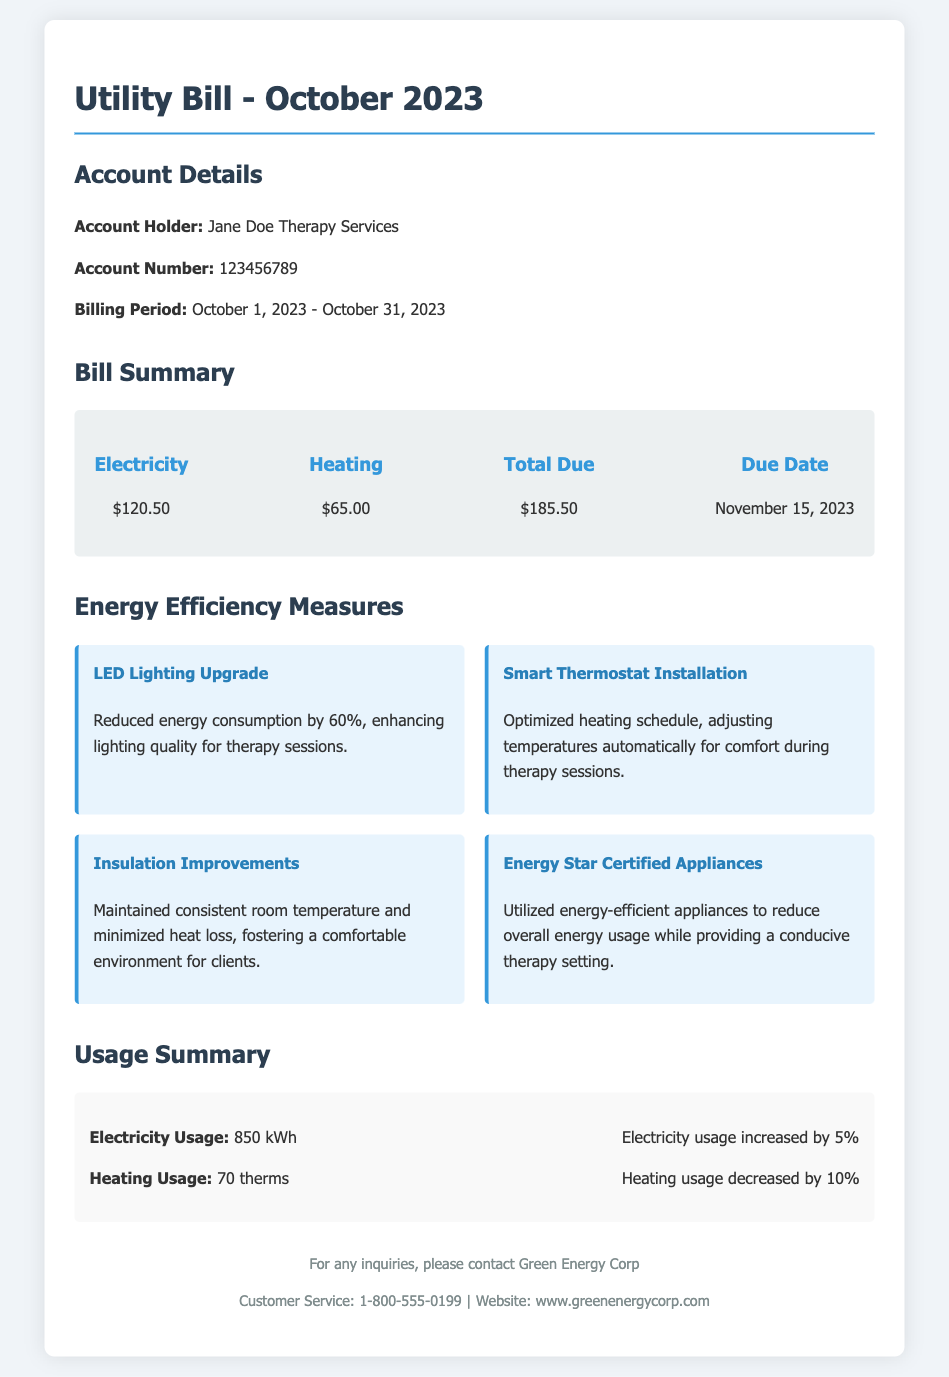what is the electricity cost? The electricity cost listed in the bill summary is clearly stated as $120.50.
Answer: $120.50 what is the heating cost? The heating cost for the billing period is provided in the bill summary, which is $65.00.
Answer: $65.00 what is the total amount due? The total amount due is the sum of electricity and heating costs, found in the bill summary as $185.50.
Answer: $185.50 when is the due date? The due date for payment of the bill is specified as November 15, 2023.
Answer: November 15, 2023 how much did electricity usage increase? The document states that electricity usage increased by 5% compared to the previous period.
Answer: 5% what energy efficiency measure reduces lighting consumption? The LED Lighting Upgrade is mentioned as reducing energy consumption by 60%, enhancing lighting quality for therapy sessions.
Answer: LED Lighting Upgrade which installation optimizes the heating schedule? The Smart Thermostat Installation is highlighted as the measure that optimizes the heating schedule automatically.
Answer: Smart Thermostat Installation what type of appliances were utilized? The document mentions the use of Energy Star Certified Appliances to reduce overall energy usage.
Answer: Energy Star Certified Appliances how many kilowatt-hours of electricity were used? The total electricity usage for the month is reported as 850 kWh.
Answer: 850 kWh how many therms of heating were used? The heating usage noted in the bill is 70 therms.
Answer: 70 therms 